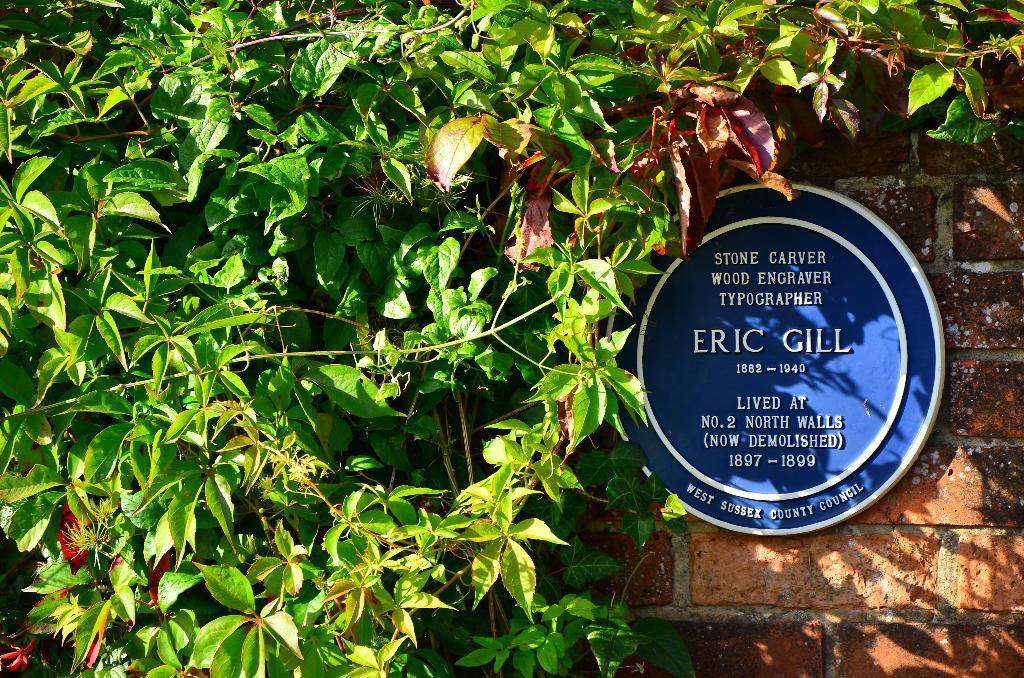Can you describe this image briefly? In this image, we can see a board with some text is placed on the wall and in the background, there are leaves. 